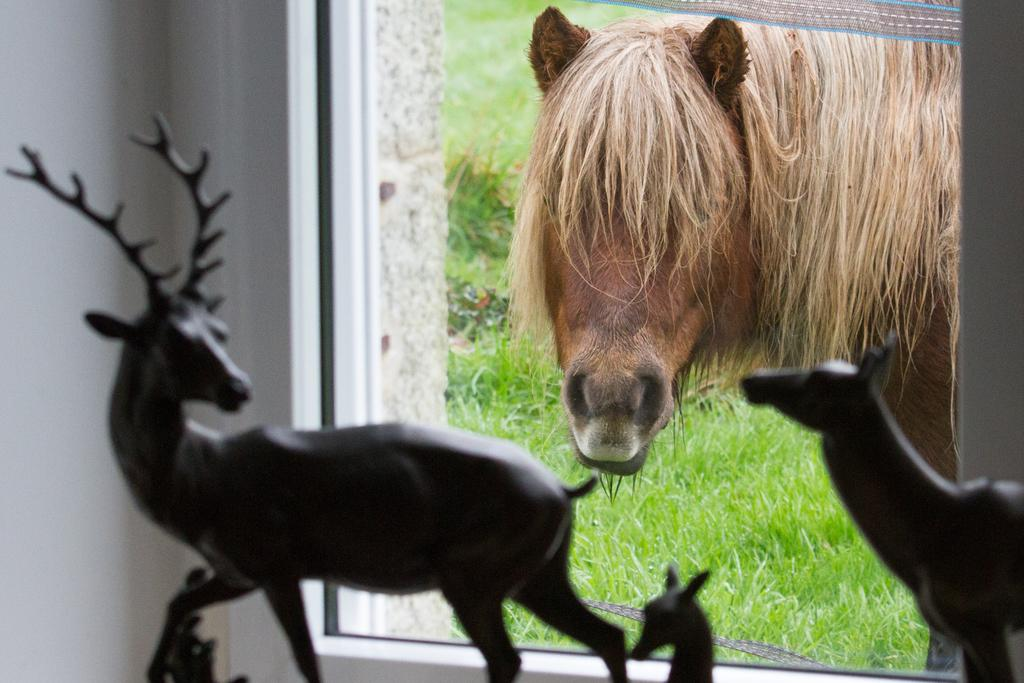What type of objects can be seen in the image? There are toy animals in the image. What architectural feature is present in the image? There is a window in the image. What can be seen outside the window? Outside the window, there is a horse and grass visible. What sound can be heard coming from the drain in the image? There is no drain present in the image, so it is not possible to determine what sound might be heard. 